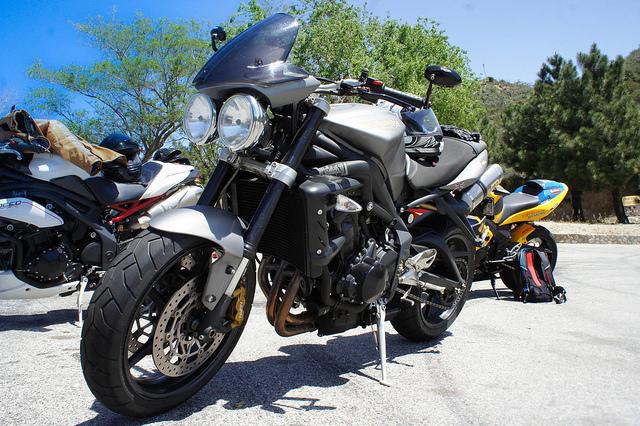Is it daytime?
Quick response, please. Yes. Are the kickstands down?
Be succinct. Yes. Do you see any motorcycle helmets?
Concise answer only. Yes. 